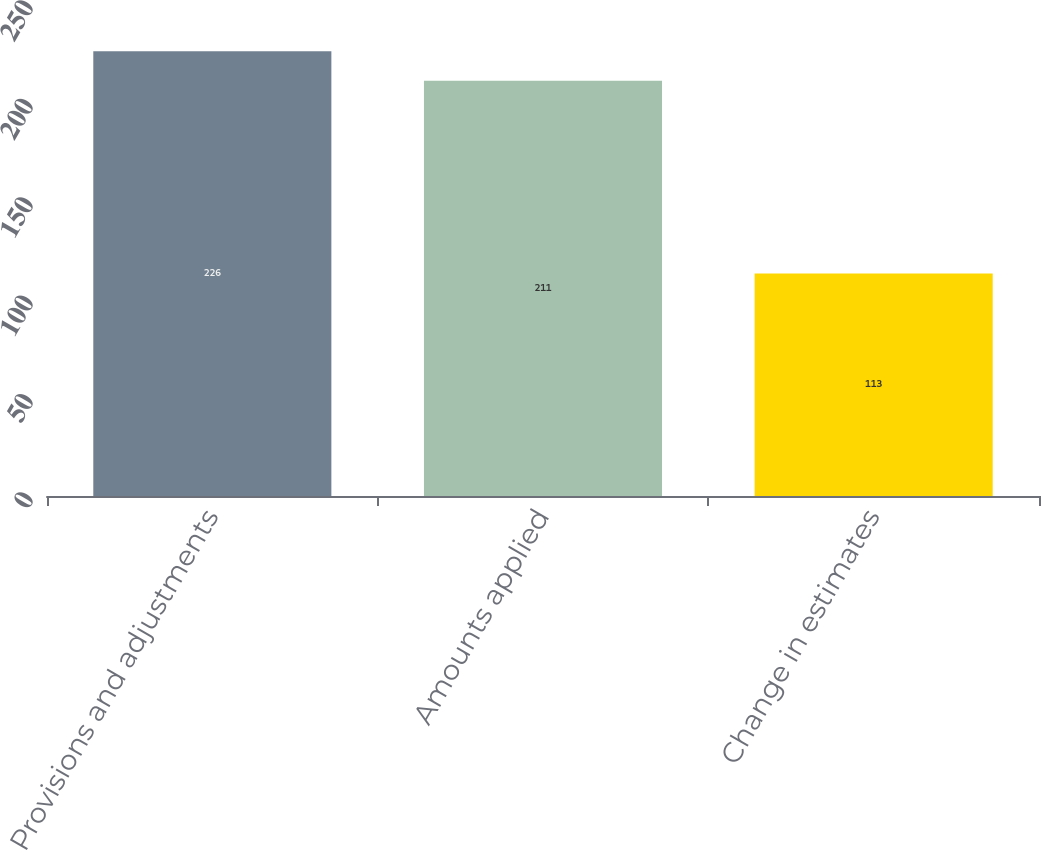Convert chart. <chart><loc_0><loc_0><loc_500><loc_500><bar_chart><fcel>Provisions and adjustments<fcel>Amounts applied<fcel>Change in estimates<nl><fcel>226<fcel>211<fcel>113<nl></chart> 